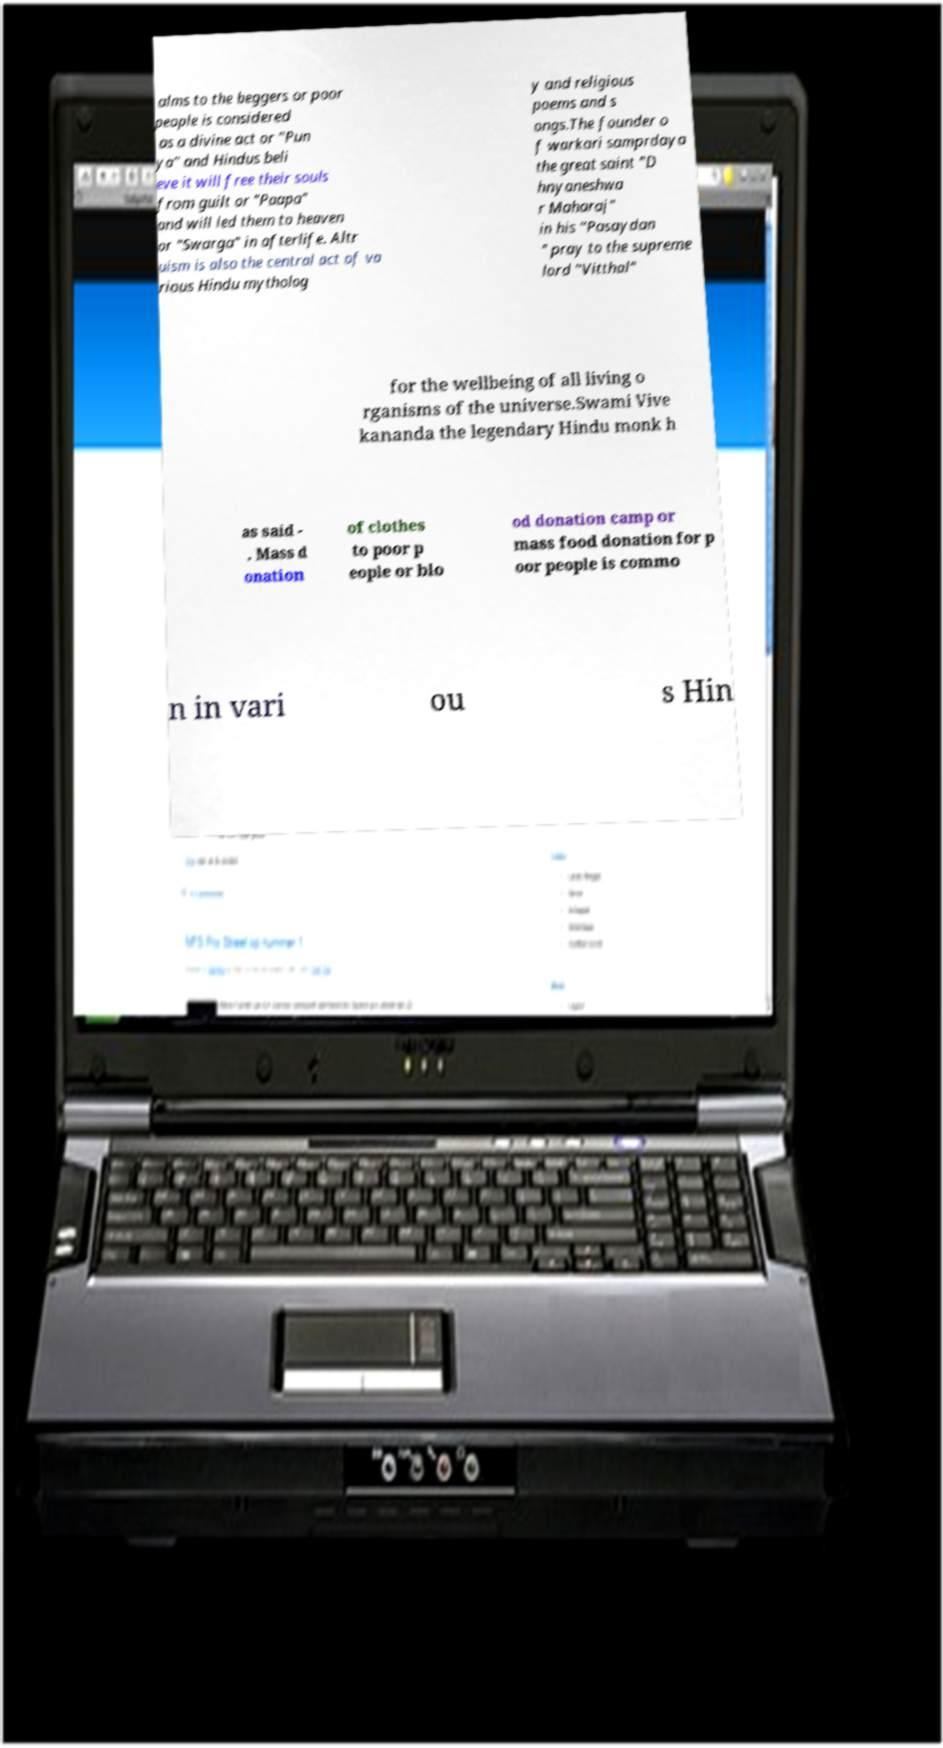Can you read and provide the text displayed in the image?This photo seems to have some interesting text. Can you extract and type it out for me? alms to the beggers or poor people is considered as a divine act or "Pun ya" and Hindus beli eve it will free their souls from guilt or "Paapa" and will led them to heaven or "Swarga" in afterlife. Altr uism is also the central act of va rious Hindu mytholog y and religious poems and s ongs.The founder o f warkari samprdaya the great saint "D hnyaneshwa r Maharaj" in his "Pasaydan " pray to the supreme lord "Vitthal" for the wellbeing of all living o rganisms of the universe.Swami Vive kananda the legendary Hindu monk h as said - . Mass d onation of clothes to poor p eople or blo od donation camp or mass food donation for p oor people is commo n in vari ou s Hin 